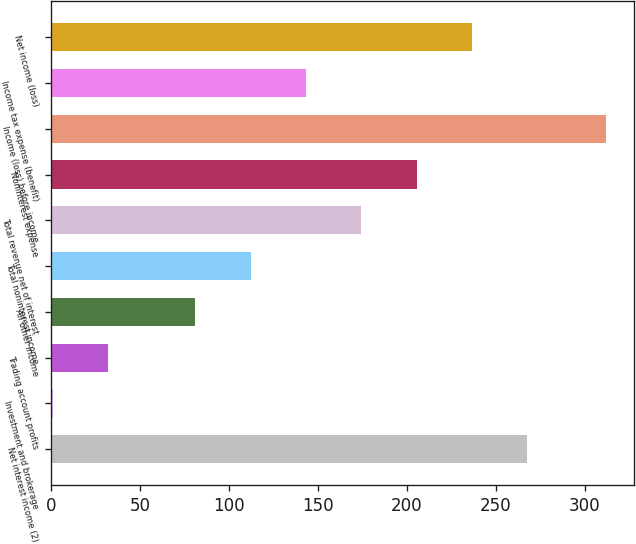<chart> <loc_0><loc_0><loc_500><loc_500><bar_chart><fcel>Net interest income (2)<fcel>Investment and brokerage<fcel>Trading account profits<fcel>All other income<fcel>Total noninterest income<fcel>Total revenue net of interest<fcel>Noninterest expense<fcel>Income (loss) before income<fcel>Income tax expense (benefit)<fcel>Net income (loss)<nl><fcel>267.6<fcel>1<fcel>32.1<fcel>81<fcel>112.1<fcel>174.3<fcel>205.4<fcel>312<fcel>143.2<fcel>236.5<nl></chart> 